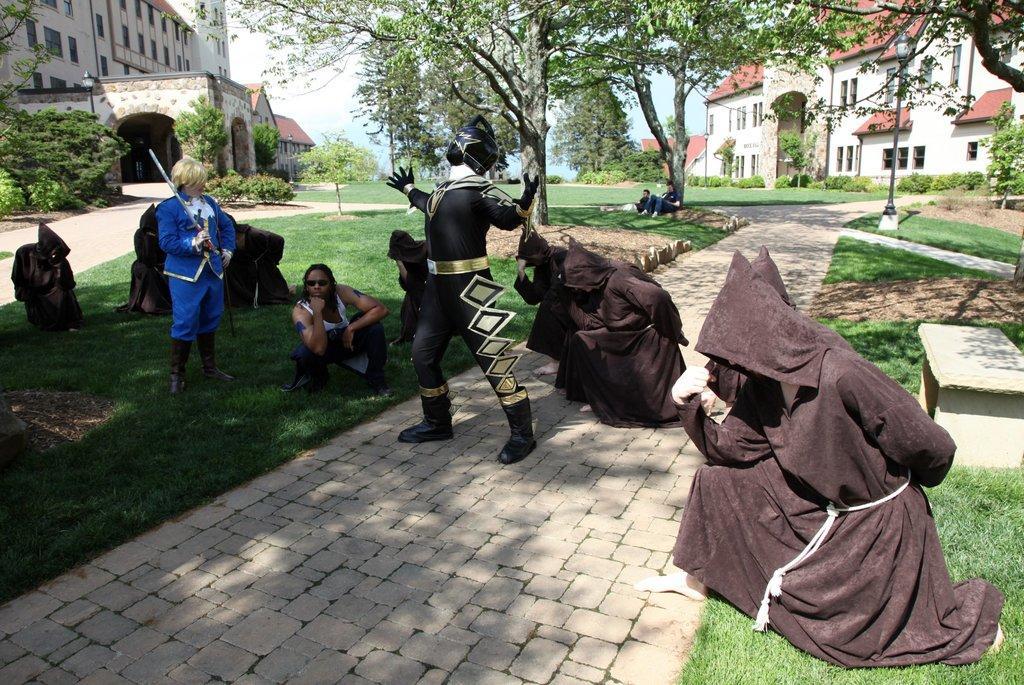How would you summarize this image in a sentence or two? In this picture we can see group of people, few people wearing costumes, on the left side of the image we can see a person and the person is holding a sword, in the background we can find few trees, buildings, poles and lights. 